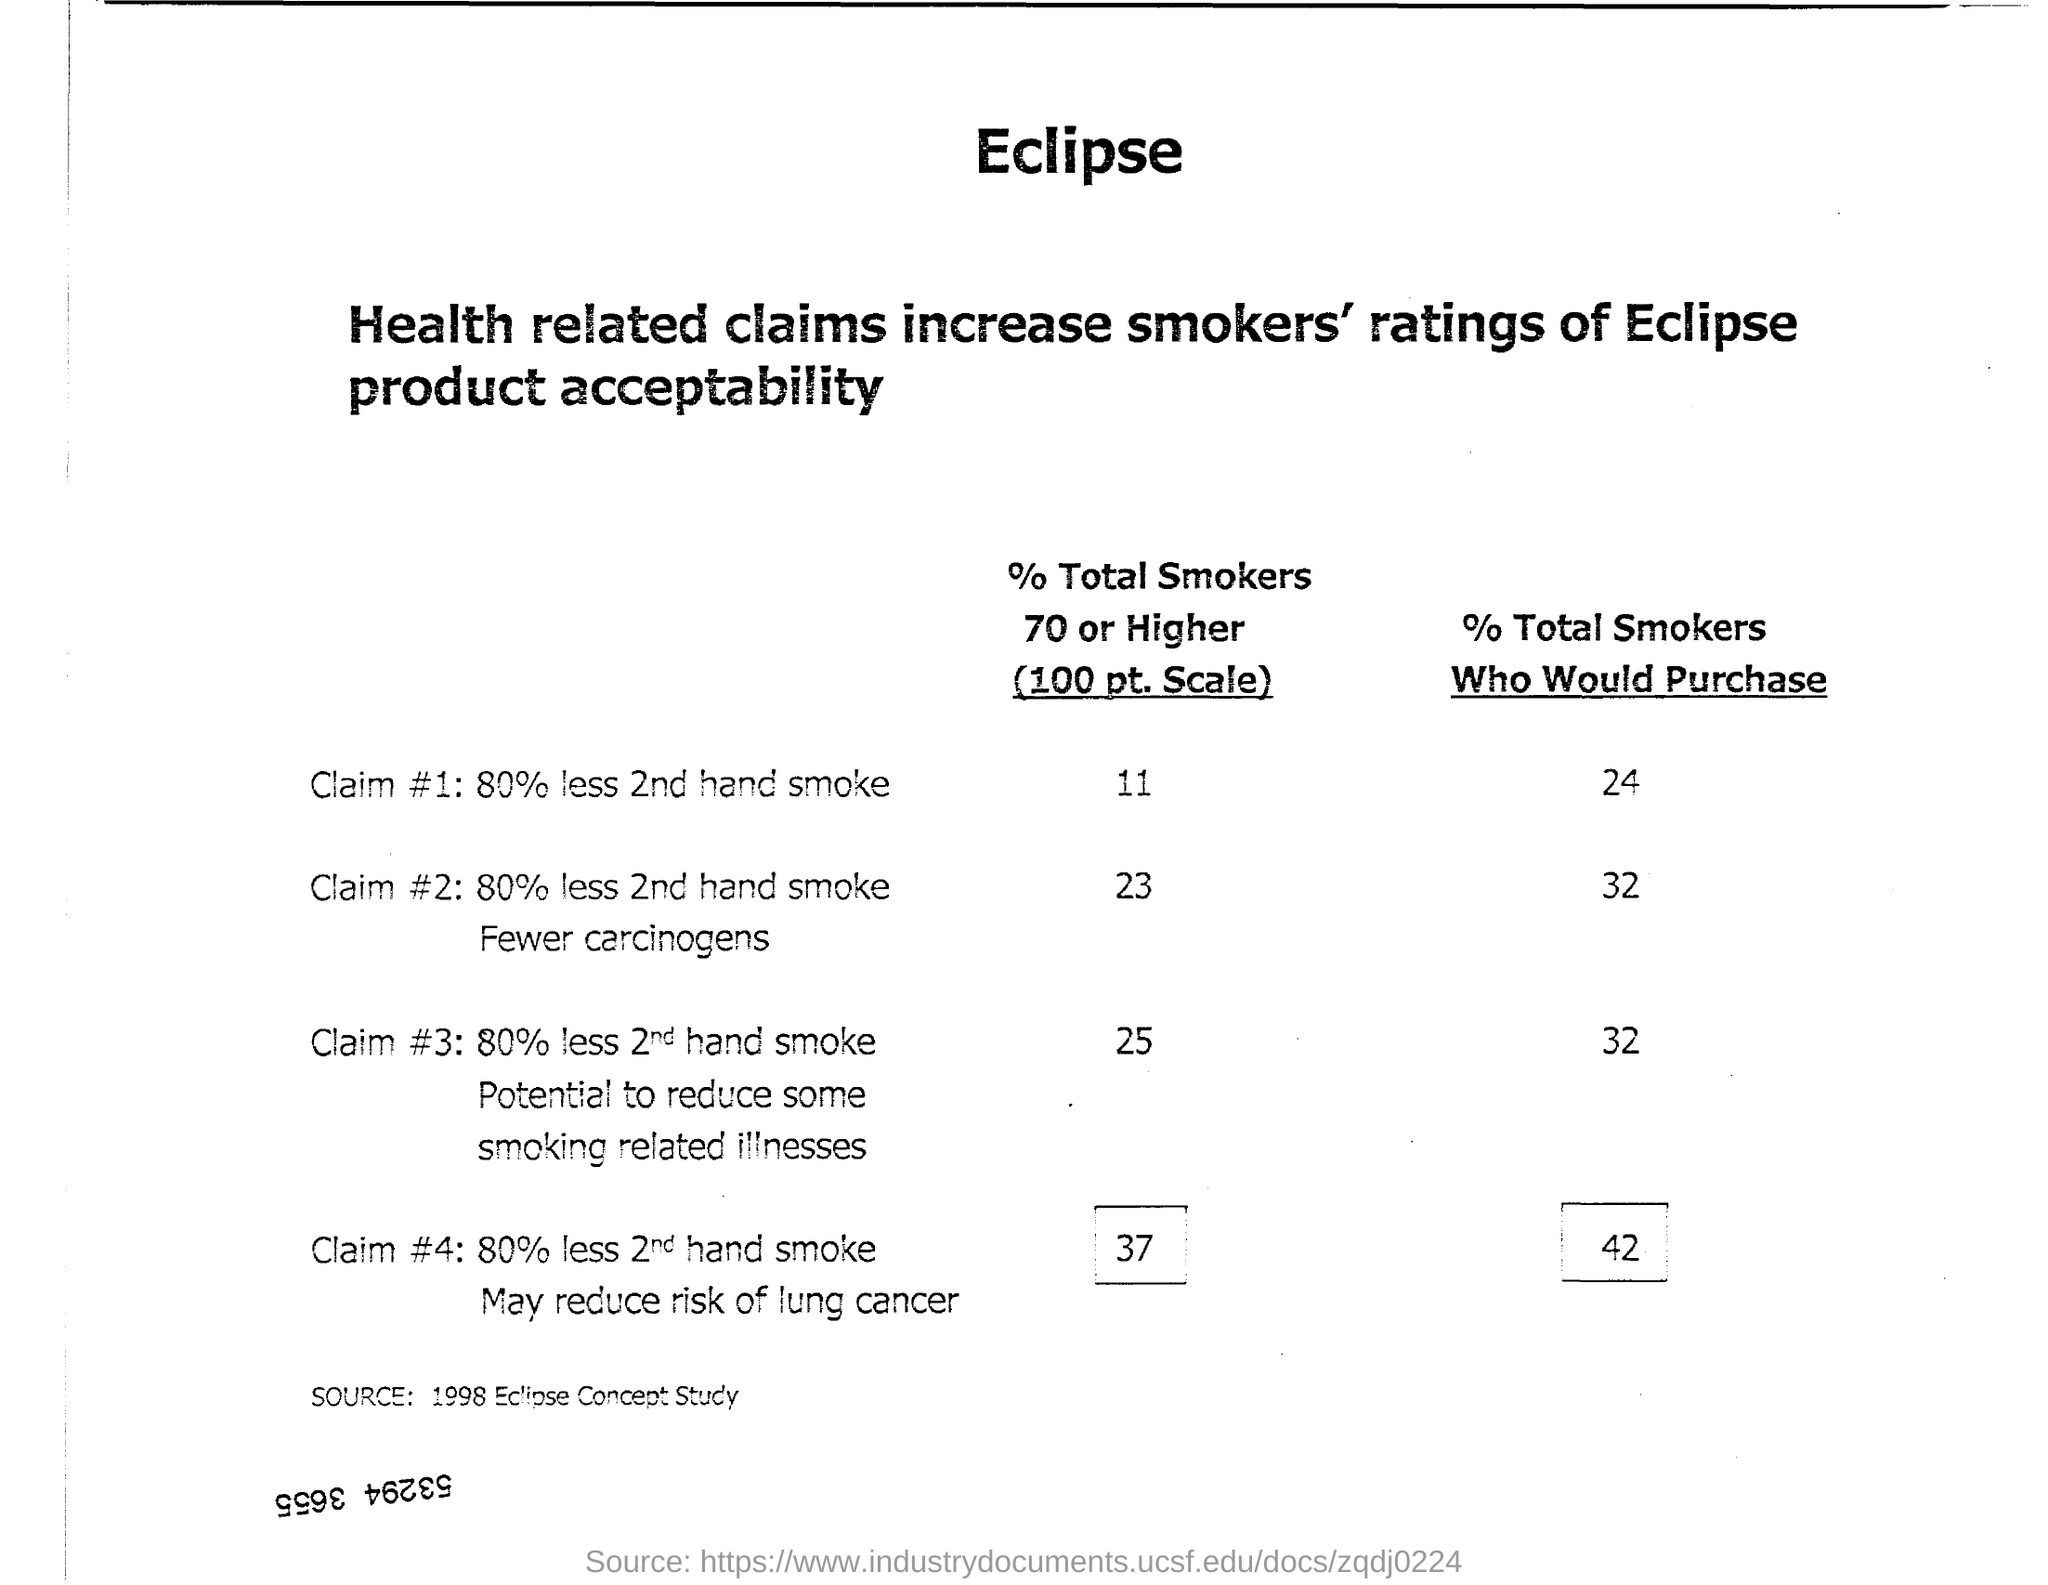What increases smoker's ratings of Eclipse product acceptability?
Offer a terse response. Health related claims. What is the source of the data given?
Your answer should be compact. 1998 Eclipse Concept Study. Which claim has the least percent of total smokers 70 or higher?
Provide a succinct answer. 80% less 2nd hand smoke. 